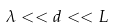Convert formula to latex. <formula><loc_0><loc_0><loc_500><loc_500>\lambda < < d < < L</formula> 